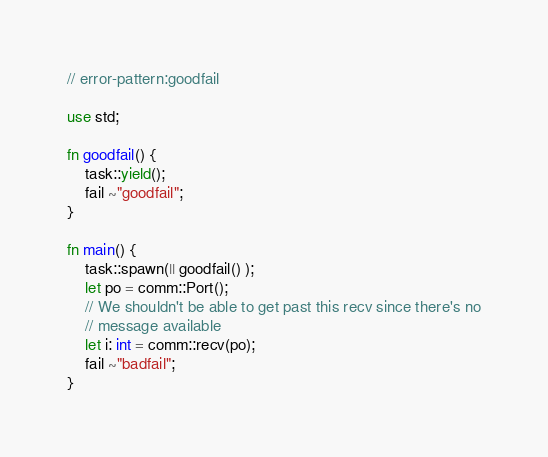Convert code to text. <code><loc_0><loc_0><loc_500><loc_500><_Rust_>// error-pattern:goodfail

use std;

fn goodfail() {
    task::yield();
    fail ~"goodfail";
}

fn main() {
    task::spawn(|| goodfail() );
    let po = comm::Port();
    // We shouldn't be able to get past this recv since there's no
    // message available
    let i: int = comm::recv(po);
    fail ~"badfail";
}
</code> 